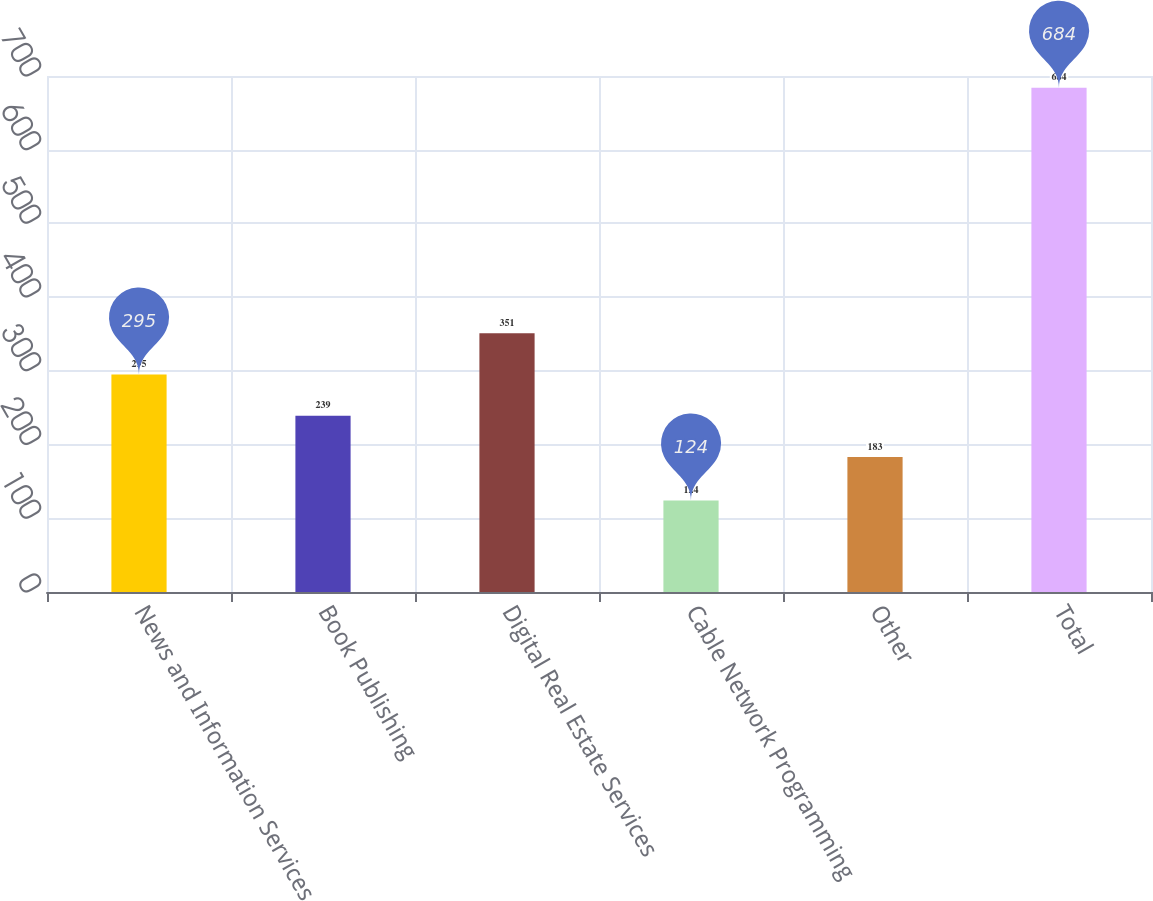Convert chart to OTSL. <chart><loc_0><loc_0><loc_500><loc_500><bar_chart><fcel>News and Information Services<fcel>Book Publishing<fcel>Digital Real Estate Services<fcel>Cable Network Programming<fcel>Other<fcel>Total<nl><fcel>295<fcel>239<fcel>351<fcel>124<fcel>183<fcel>684<nl></chart> 